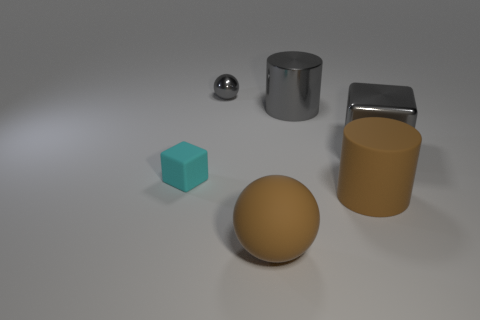Add 3 big brown rubber cylinders. How many objects exist? 9 Subtract all cylinders. How many objects are left? 4 Subtract 0 purple cylinders. How many objects are left? 6 Subtract all gray cubes. Subtract all gray balls. How many objects are left? 4 Add 4 rubber cylinders. How many rubber cylinders are left? 5 Add 2 tiny rubber cubes. How many tiny rubber cubes exist? 3 